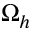<formula> <loc_0><loc_0><loc_500><loc_500>\Omega _ { h }</formula> 